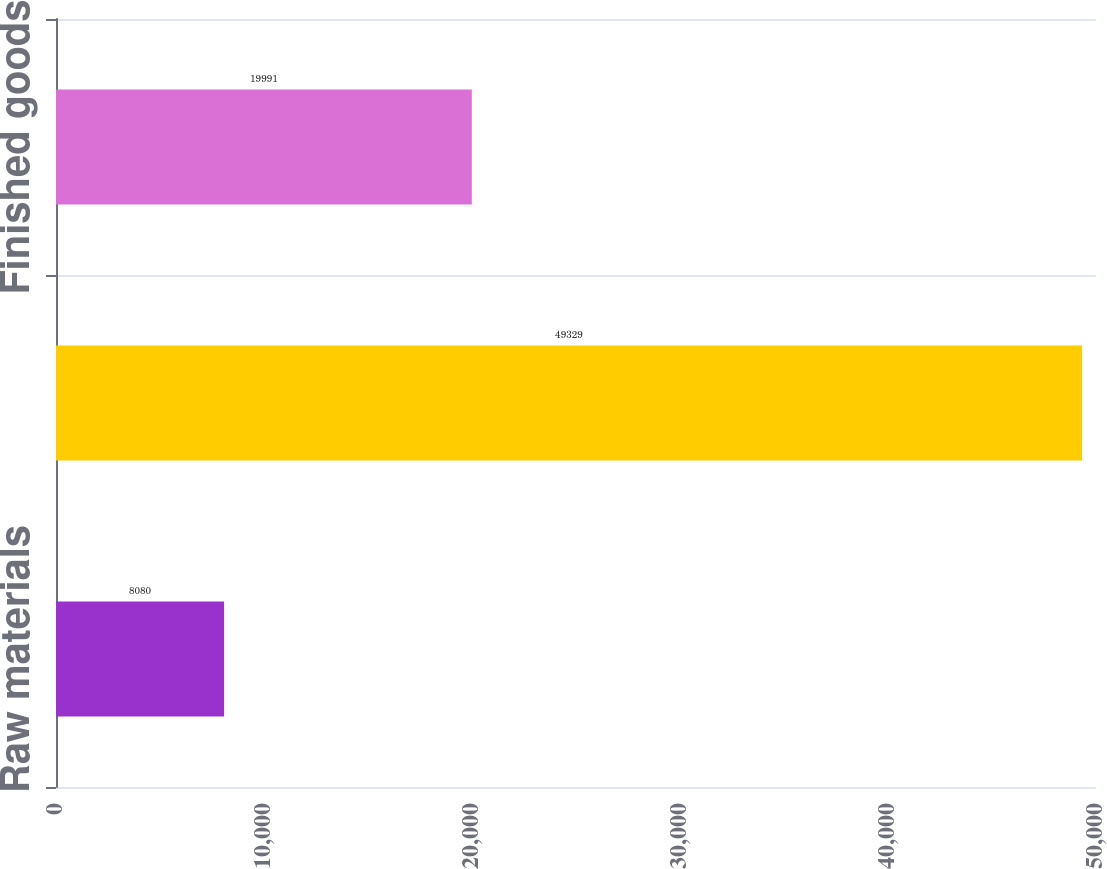Convert chart. <chart><loc_0><loc_0><loc_500><loc_500><bar_chart><fcel>Raw materials<fcel>Work-in-process<fcel>Finished goods<nl><fcel>8080<fcel>49329<fcel>19991<nl></chart> 